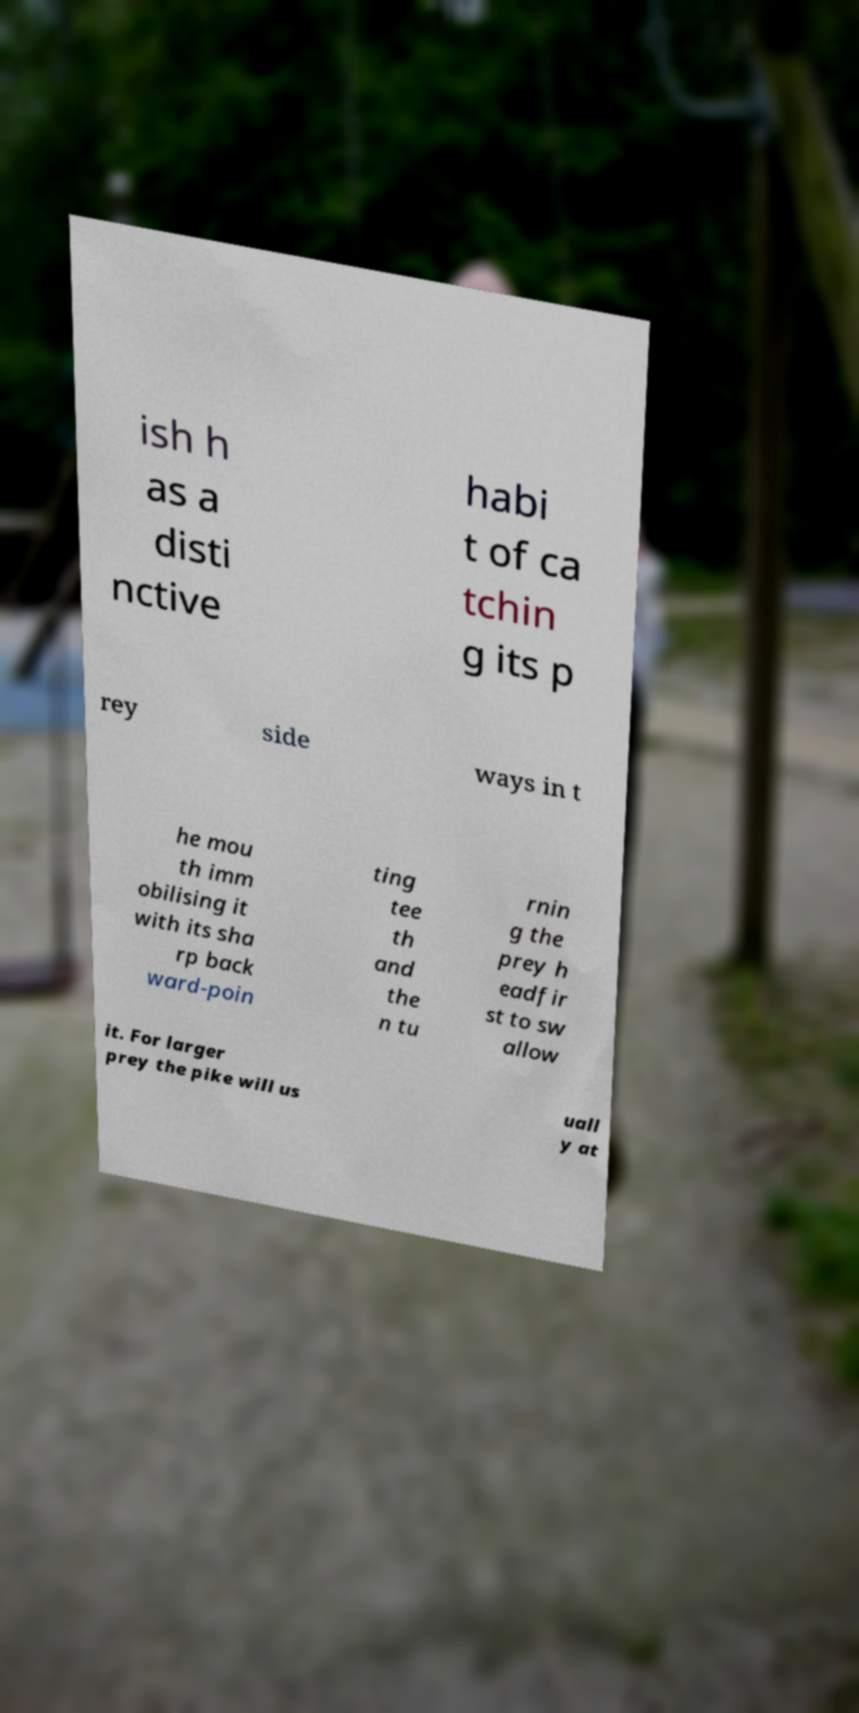Please read and relay the text visible in this image. What does it say? ish h as a disti nctive habi t of ca tchin g its p rey side ways in t he mou th imm obilising it with its sha rp back ward-poin ting tee th and the n tu rnin g the prey h eadfir st to sw allow it. For larger prey the pike will us uall y at 